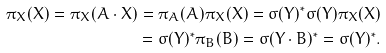Convert formula to latex. <formula><loc_0><loc_0><loc_500><loc_500>\pi _ { X } ( X ) = \pi _ { X } ( A \cdot X ) = \pi _ { A } ( A ) \pi _ { X } ( X ) = \sigma ( Y ) ^ { * } \sigma ( Y ) \pi _ { X } ( X ) \\ = \sigma ( Y ) ^ { * } \pi _ { B } ( B ) = \sigma ( Y \cdot B ) ^ { * } = \sigma ( Y ) ^ { * } .</formula> 